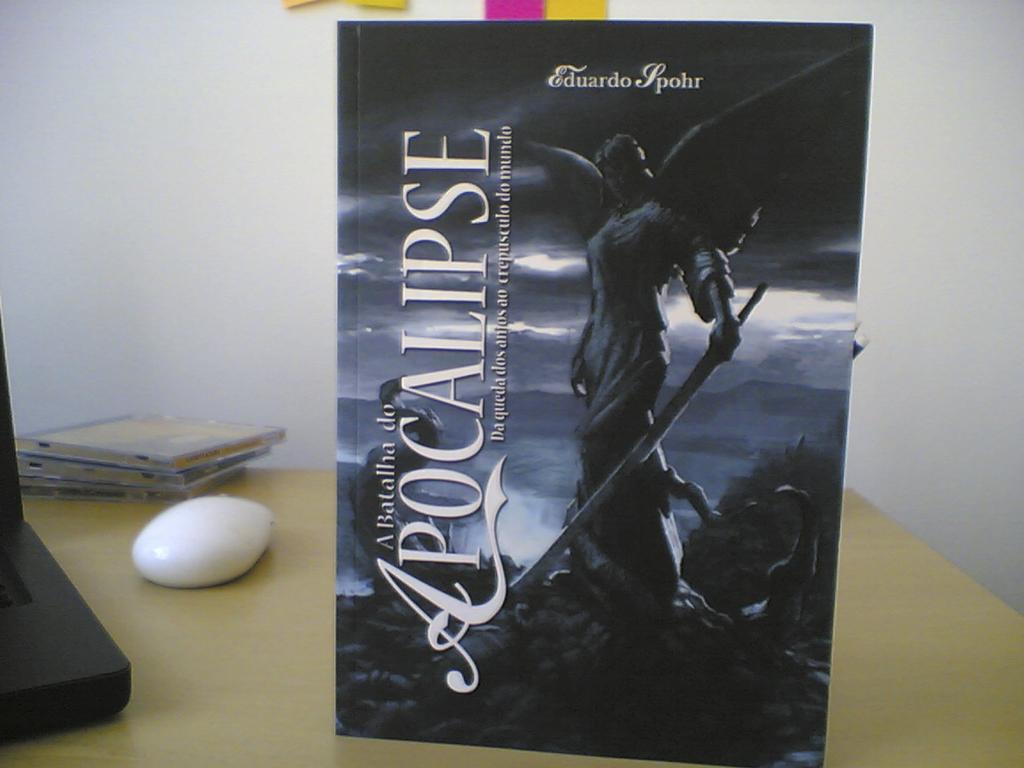What is the title of this book?
Ensure brevity in your answer.  Apocalipse. 